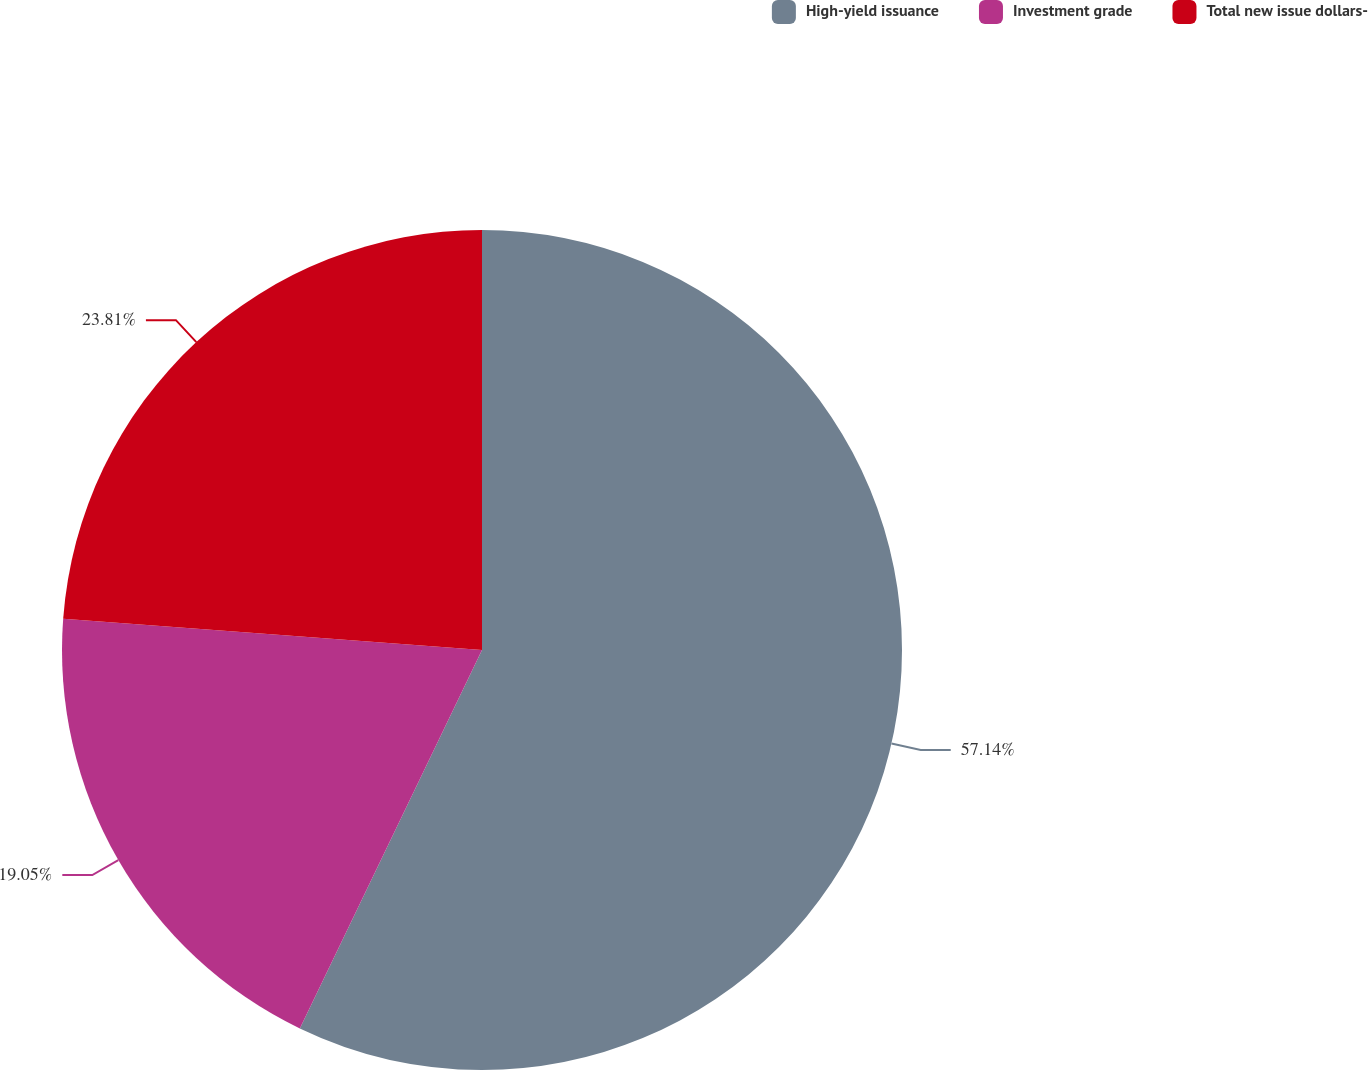<chart> <loc_0><loc_0><loc_500><loc_500><pie_chart><fcel>High-yield issuance<fcel>Investment grade<fcel>Total new issue dollars-<nl><fcel>57.14%<fcel>19.05%<fcel>23.81%<nl></chart> 